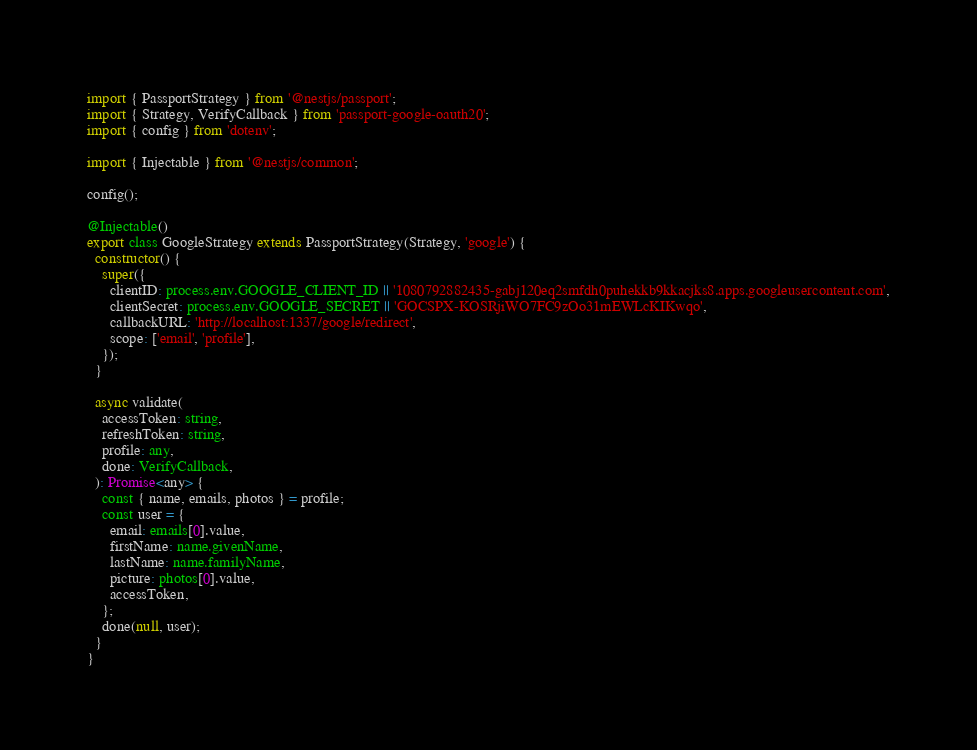<code> <loc_0><loc_0><loc_500><loc_500><_TypeScript_>import { PassportStrategy } from '@nestjs/passport';
import { Strategy, VerifyCallback } from 'passport-google-oauth20';
import { config } from 'dotenv';

import { Injectable } from '@nestjs/common';

config();

@Injectable()
export class GoogleStrategy extends PassportStrategy(Strategy, 'google') {
  constructor() {
    super({
      clientID: process.env.GOOGLE_CLIENT_ID || '1080792882435-gabj120eq2smfdh0puhekkb9kkacjks8.apps.googleusercontent.com',
      clientSecret: process.env.GOOGLE_SECRET || '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',
      callbackURL: 'http://localhost:1337/google/redirect',
      scope: ['email', 'profile'],
    });
  }

  async validate(
    accessToken: string,
    refreshToken: string,
    profile: any,
    done: VerifyCallback,
  ): Promise<any> {
    const { name, emails, photos } = profile;
    const user = {
      email: emails[0].value,
      firstName: name.givenName,
      lastName: name.familyName,
      picture: photos[0].value,
      accessToken,
    };
    done(null, user);
  }
}
</code> 